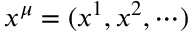<formula> <loc_0><loc_0><loc_500><loc_500>x ^ { \mu } = ( x ^ { 1 } , x ^ { 2 } , \cdots )</formula> 